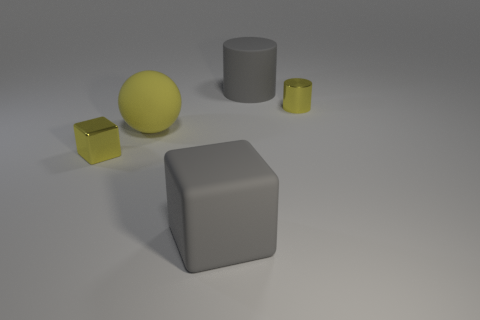Add 3 rubber cylinders. How many objects exist? 8 Subtract all yellow cylinders. How many cylinders are left? 1 Subtract 2 cylinders. How many cylinders are left? 0 Subtract all blocks. How many objects are left? 3 Subtract all purple blocks. Subtract all green cylinders. How many blocks are left? 2 Subtract all purple cylinders. How many gray spheres are left? 0 Subtract all gray blocks. Subtract all gray rubber cubes. How many objects are left? 3 Add 4 big matte blocks. How many big matte blocks are left? 5 Add 5 large brown cubes. How many large brown cubes exist? 5 Subtract 1 gray blocks. How many objects are left? 4 